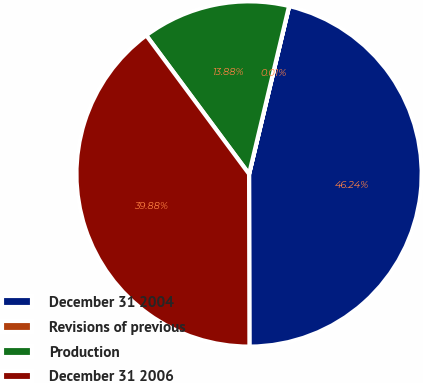Convert chart. <chart><loc_0><loc_0><loc_500><loc_500><pie_chart><fcel>December 31 2004<fcel>Revisions of previous<fcel>Production<fcel>December 31 2006<nl><fcel>46.24%<fcel>0.01%<fcel>13.88%<fcel>39.88%<nl></chart> 